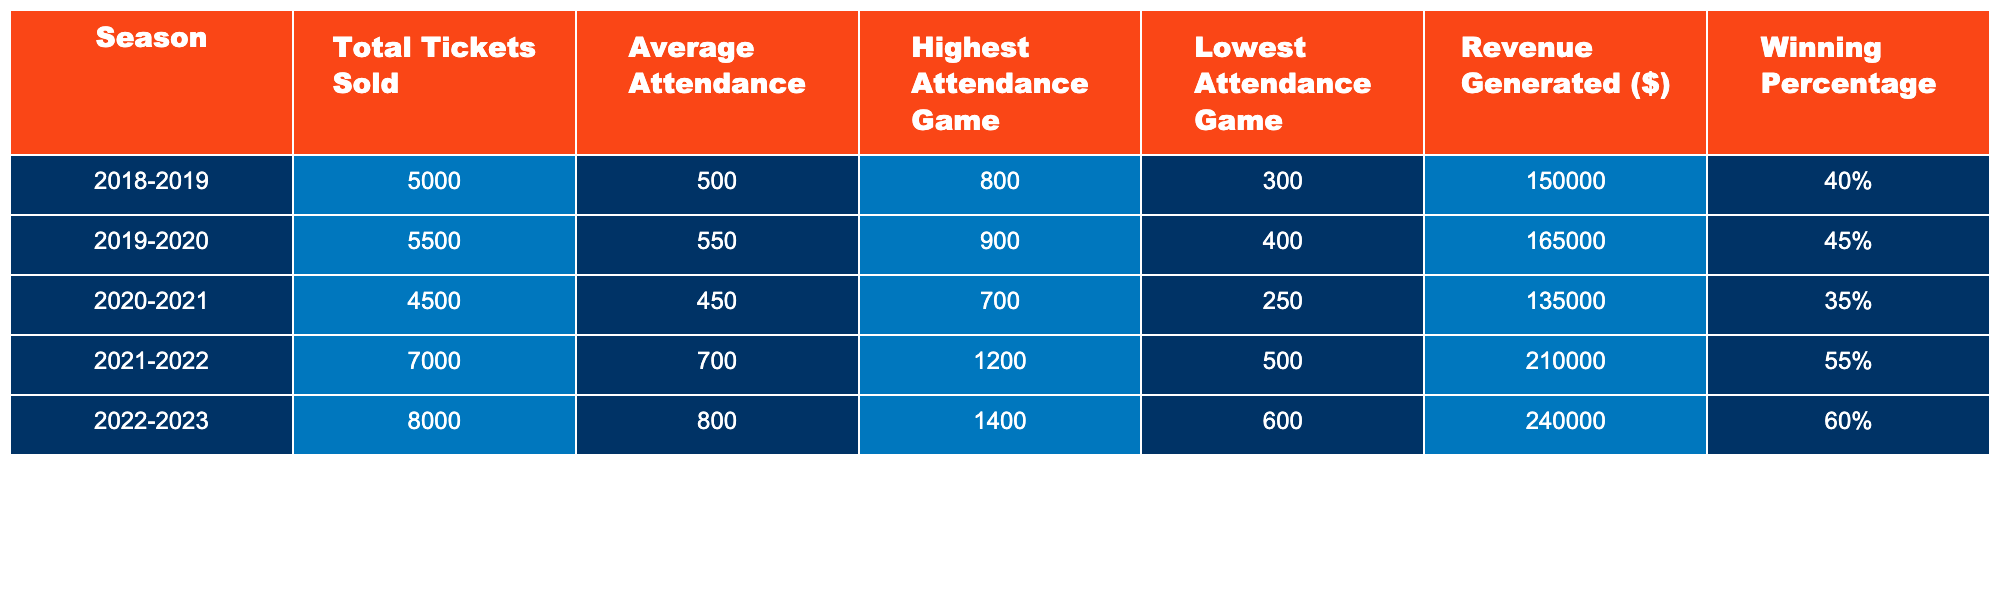What was the total revenue generated in the 2022-2023 season? From the table, the revenue generated in the 2022-2023 season is listed directly as $240,000.
Answer: $240,000 Which season had the highest average attendance? The table shows that the average attendance during the 2022-2023 season is 800, which is higher than all other seasons listed.
Answer: 2022-2023 What is the difference in total tickets sold between the 2018-2019 and 2021-2022 seasons? In the 2018-2019 season, 5,000 tickets were sold, and in the 2021-2022 season, 7,000 tickets were sold. The difference is 7,000 - 5,000 = 2,000.
Answer: 2,000 Did the Florida Atlantic Owls have a higher winning percentage in the 2021-2022 season or the 2022-2023 season? The winning percentage for the 2021-2022 season is 55%, while for the 2022-2023 season it is 60%. Thus, the 2022-2023 season had a higher winning percentage.
Answer: Yes What was the average winning percentage over the five seasons? To calculate the average winning percentage, we add the winning percentages: 40% + 45% + 35% + 55% + 60% = 235%. Then we divide by 5, which gives us an average of 235% / 5 = 47%.
Answer: 47% Which season had the lowest attendance at a game, and what was that attendance? The lowest attendance recorded in a game was 250 during the 2020-2021 season, which can be found in the respective column of the table.
Answer: 2020-2021, 250 What was the total number of tickets sold during the two seasons with the highest attendance? The two highest attendance years are 2022-2023 (8,000 tickets) and 2021-2022 (7,000 tickets). Their total is 8,000 + 7,000 = 15,000 tickets sold.
Answer: 15,000 Is there a trend in ticket sales over the seasons? By observing the total tickets sold each season in the table, we can see that ticket sales increased each season from 2018-2019 to 2022-2023, indicating a positive trend.
Answer: Yes How many more tickets were sold in the 2019-2020 season than in the 2020-2021 season? In the 2019-2020 season, 5,500 tickets were sold, and in the 2020-2021 season, 4,500 tickets were sold. The difference is 5,500 - 4,500 = 1,000.
Answer: 1,000 What is the highest attendance recorded in a game across all seasons? The highest attendance in a game is listed as 1,400 for the 2022-2023 season, which is confirmed by looking at the appropriate column in the table.
Answer: 1,400 